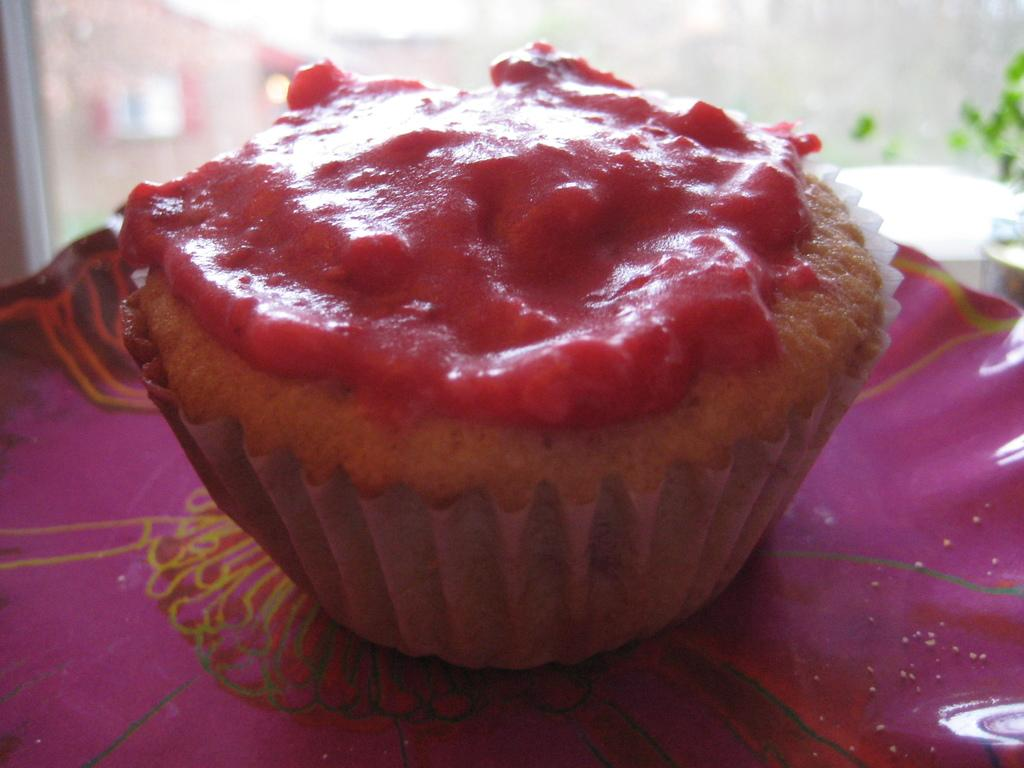What type of food is on the plate in the image? There is a cupcake on a plate in the image. What color is the plate? The plate is pink. What can be seen through the glass window in the image? There are buildings and a plant visible outside the window. Can you tell me how many veins are visible on the cupcake in the image? There are no veins visible on the cupcake in the image, as veins are not a characteristic of cupcakes. 